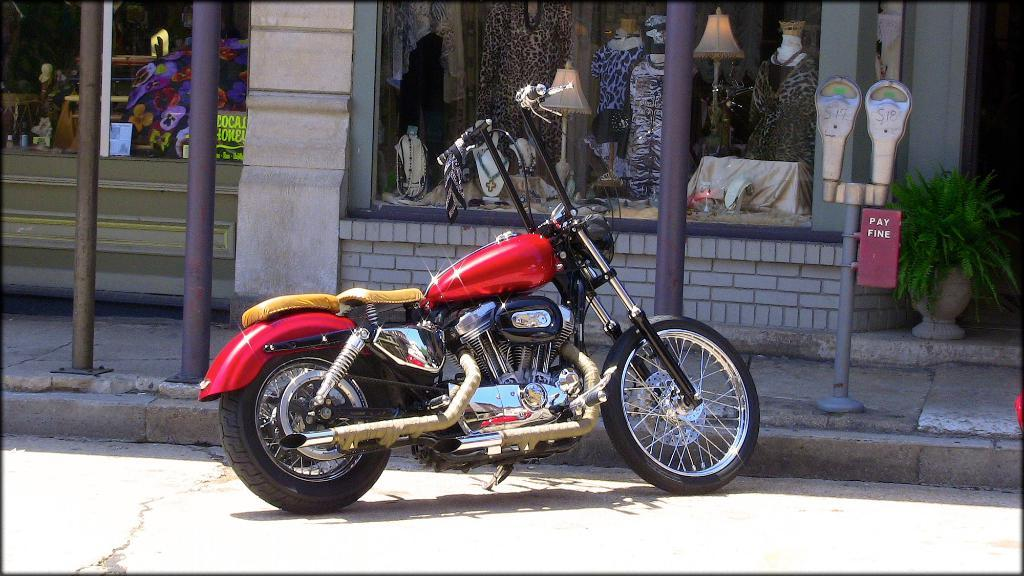What type of vehicle is on the road in the image? There is a motorbike on the road in the image. What objects can be seen in the image besides the motorbike? There are poles, meters, a house plant, mannequins, lamps, and some unspecified objects in the image. Can you describe the background of the image? In the background, there are mannequins, lamps, and some unspecified objects. What type of plant is present in the image? There is a house plant in the image. What type of lace is used to decorate the motorbike in the image? There is no lace present on the motorbike in the image. What channel is the motorbike tuned to while it's on the road? Motorbikes do not have channels, as they are not electronic devices with tuning capabilities. 